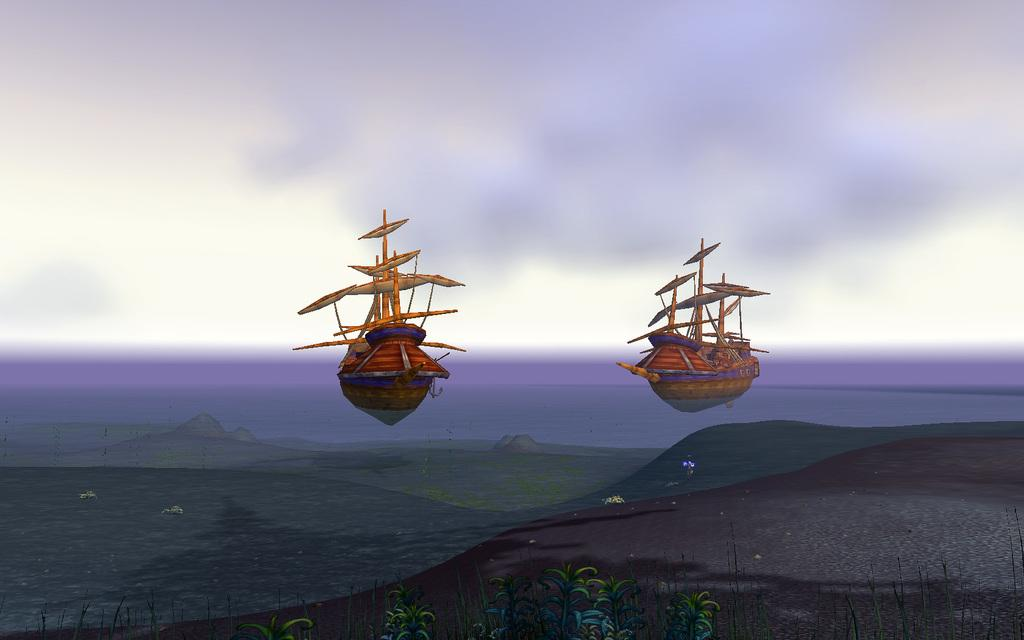What is the main subject of the image? The main subject of the image is two boats. Where are the boats located? The boats are on the water in the center of the image. What is the condition of the sky in the image? The sky is cloudy in the image. What can be seen in the front of the image? There are plants in the front of the image. What word is being spoken by the plants in the image? There are no words spoken by the plants in the image, as plants do not have the ability to speak. 